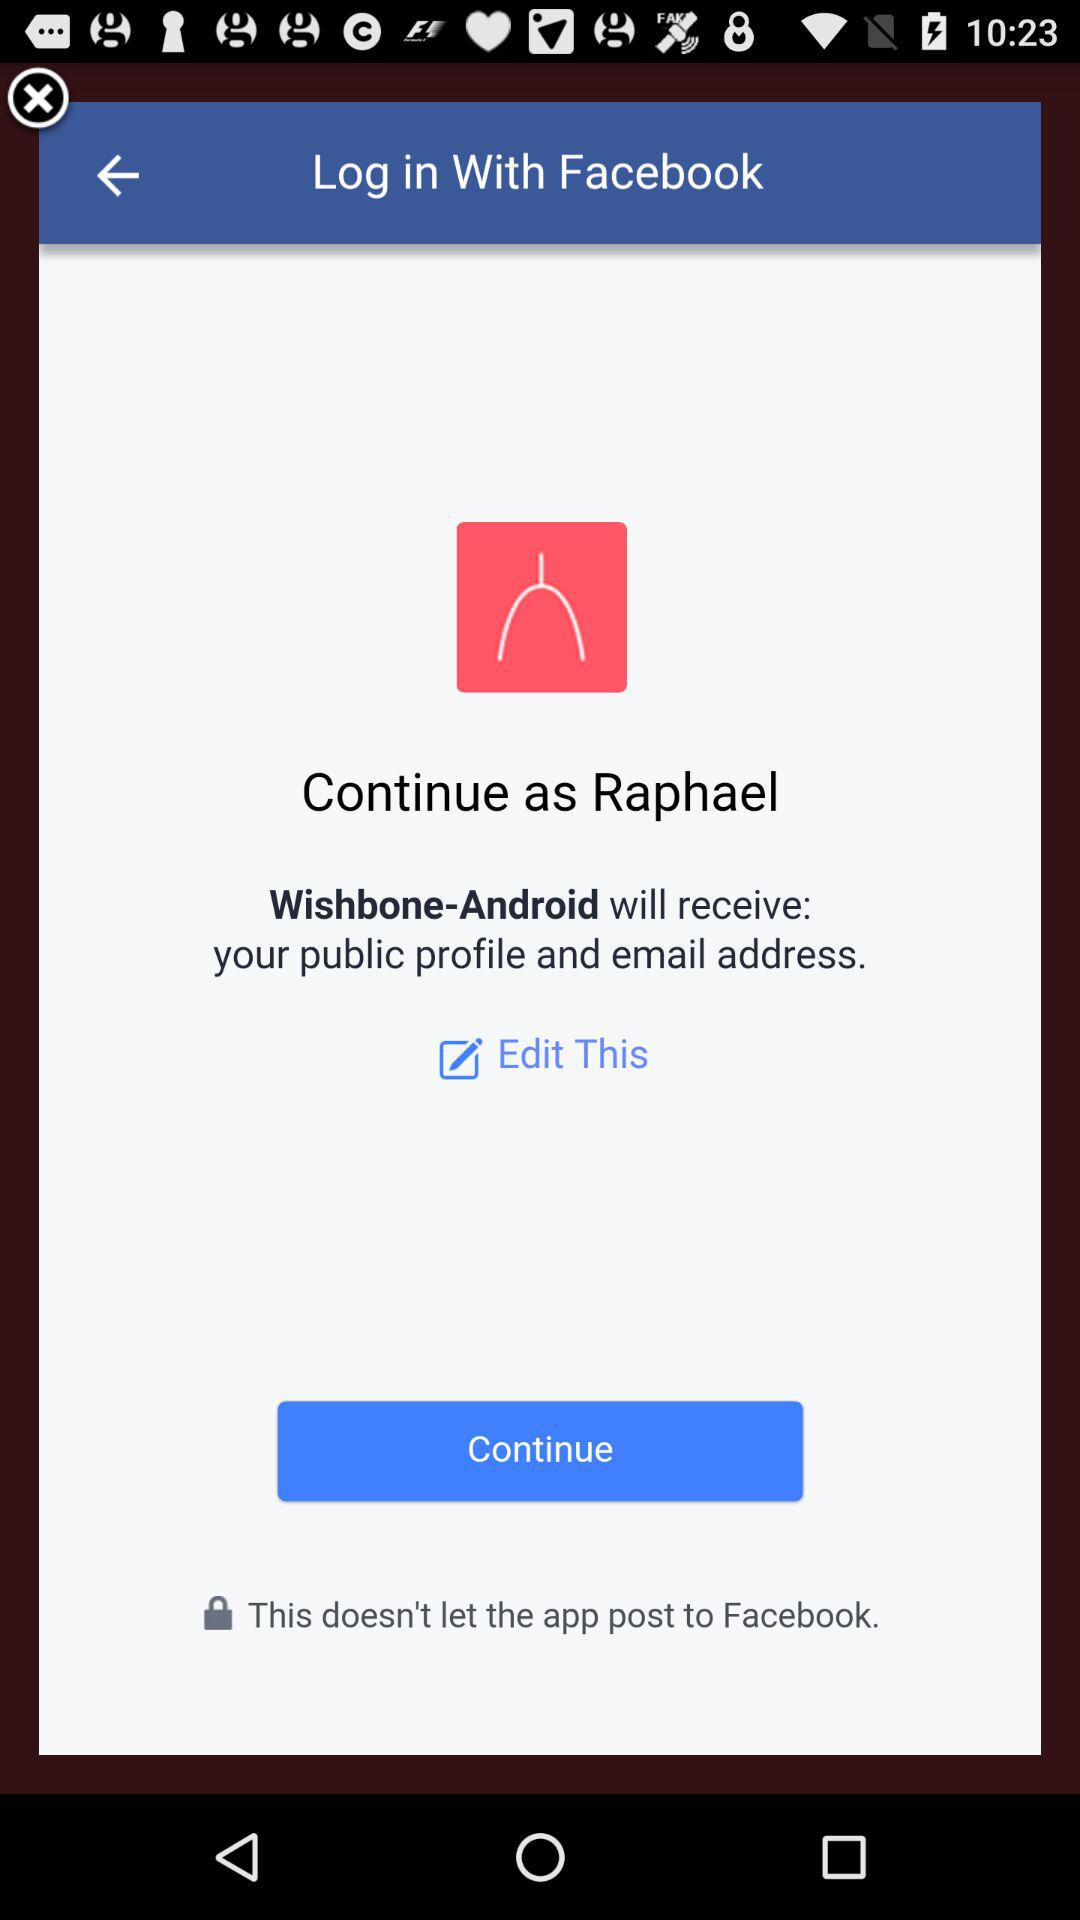What is the name of the user? The name of the user is Raphael. 